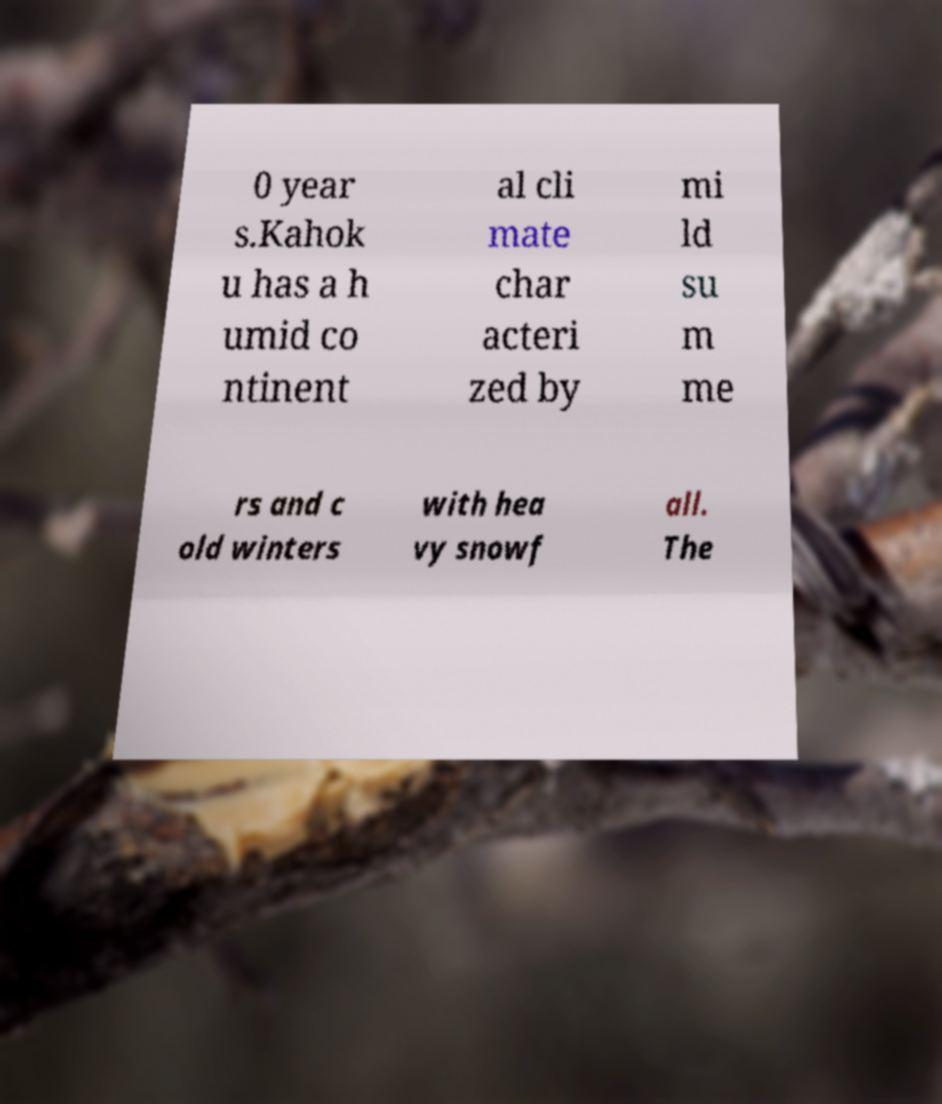Could you extract and type out the text from this image? 0 year s.Kahok u has a h umid co ntinent al cli mate char acteri zed by mi ld su m me rs and c old winters with hea vy snowf all. The 